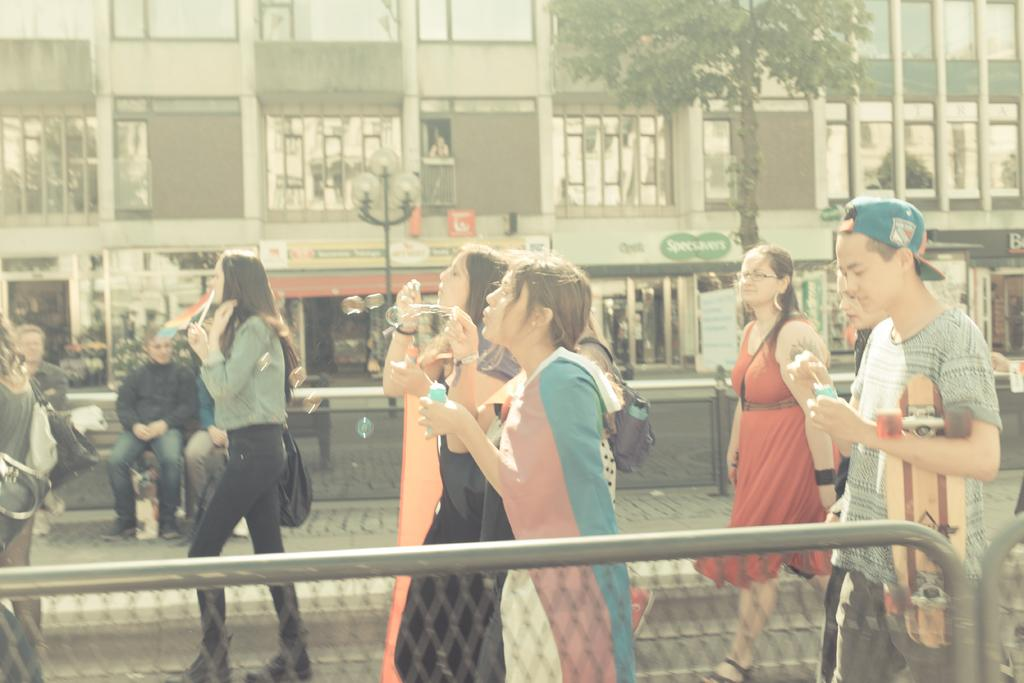What are the people in the image doing? The people in the image are walking on the road. What are the people holding while walking? The people are holding objects. What can be seen in the foreground of the image? There is a fence in the image. What is visible in the background of the image? There is a building, a tree, and a light pole in the background. Where is the spoon placed on the shelf in the image? There is no spoon or shelf present in the image. 